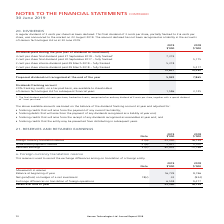Looking at Hansen Technologies's financial data, please calculate: What was the 2019 percentage change of dividends paid between 2018 and 2019 financial years? To answer this question, I need to perform calculations using the financial data. The calculation is: (12,637 - 10,392) / 10,392 , which equals 21.6 (percentage). This is based on the information: "12,637 10,392 12,637 10,392..." The key data points involved are: 10,392, 12,637. Also, can you calculate: How many proposed dividends were not recognised at the end of both years? Based on the calculation: 5,922 + 7,865 , the result is 13787 (in thousands). This is based on the information: "ed dividend not recognised at the end of the year 5,922 7,865 idend not recognised at the end of the year 5,922 7,865..." The key data points involved are: 5,922, 7,865. Also, How much was the regular dividend per share? According to the financial document, 3 cents per share. The relevant text states: "A regular dividend of 3 cents per share has been declared. This final dividend of 3 cents per share, partially franked to 2.6 cents per sha A regular dividend of 3 cents per share has been declared. T..." Also, How much was the partially franked dividendper share? This final dividend of 3 cents per share, partially franked to 2.6 cents per share. The document states: "dividend of 3 cents per share has been declared. This final dividend of 3 cents per share, partially franked to 2.6 cents per share, was announced to ..." Also, What was the final dividend of 4 cents per share comprised of? 1. The final dividend paid of 4 cents per share, franked to 4 cents, comprised of an ordinary dividend of 3 cents per share, together with a special dividend of 1 cent per share.. The document states: "1. The final dividend paid of 4 cents per share, franked to 4 cents, comprised of an ordinary dividend of 3 cents per share, together with a special d..." Also, can you calculate: What was the percentage change in franking credits between 2018 and 2019? To answer this question, I need to perform calculations using the financial data. The calculation is: (1,586 - 3,125) / 3,125 , which equals -49.25 (percentage). This is based on the information: "nologies Ltd for subsequent financial years 1,586 3,125 n Technologies Ltd for subsequent financial years 1,586 3,125..." The key data points involved are: 1,586, 3,125. 